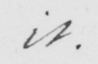Please provide the text content of this handwritten line. it . 